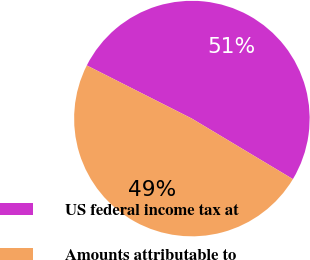<chart> <loc_0><loc_0><loc_500><loc_500><pie_chart><fcel>US federal income tax at<fcel>Amounts attributable to<nl><fcel>51.14%<fcel>48.86%<nl></chart> 